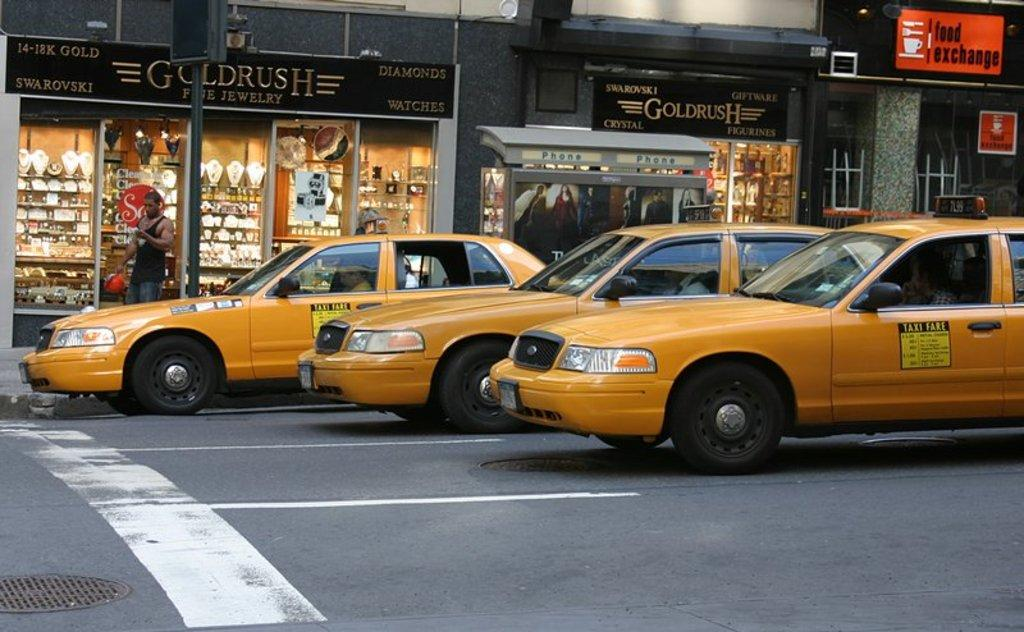<image>
Relay a brief, clear account of the picture shown. Taxis have their fare on the side so people can estimate how expensive the trip will be. 